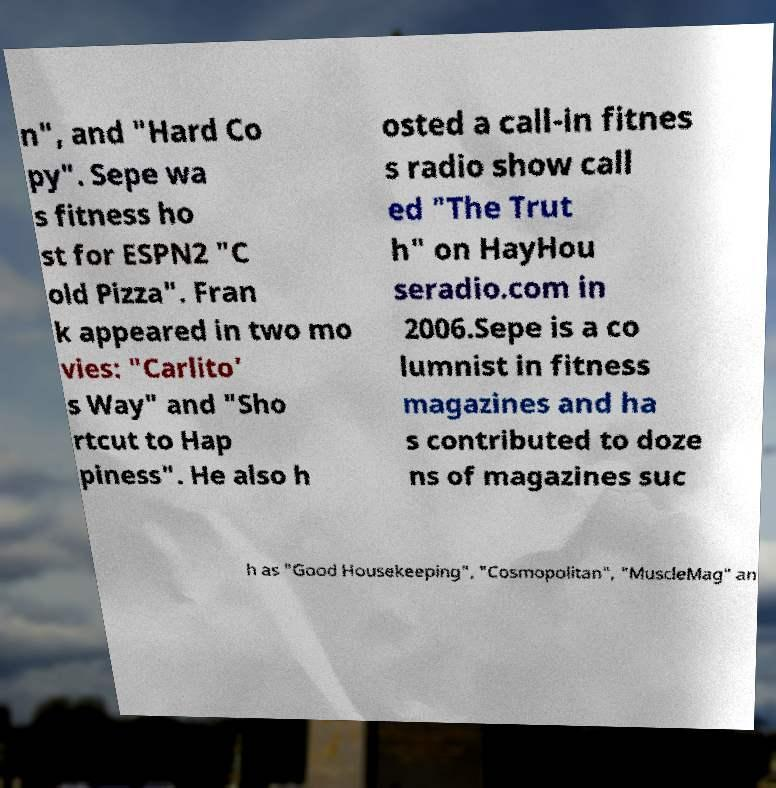Could you assist in decoding the text presented in this image and type it out clearly? n", and "Hard Co py". Sepe wa s fitness ho st for ESPN2 "C old Pizza". Fran k appeared in two mo vies: "Carlito' s Way" and "Sho rtcut to Hap piness". He also h osted a call-in fitnes s radio show call ed "The Trut h" on HayHou seradio.com in 2006.Sepe is a co lumnist in fitness magazines and ha s contributed to doze ns of magazines suc h as "Good Housekeeping", "Cosmopolitan", "MuscleMag" an 